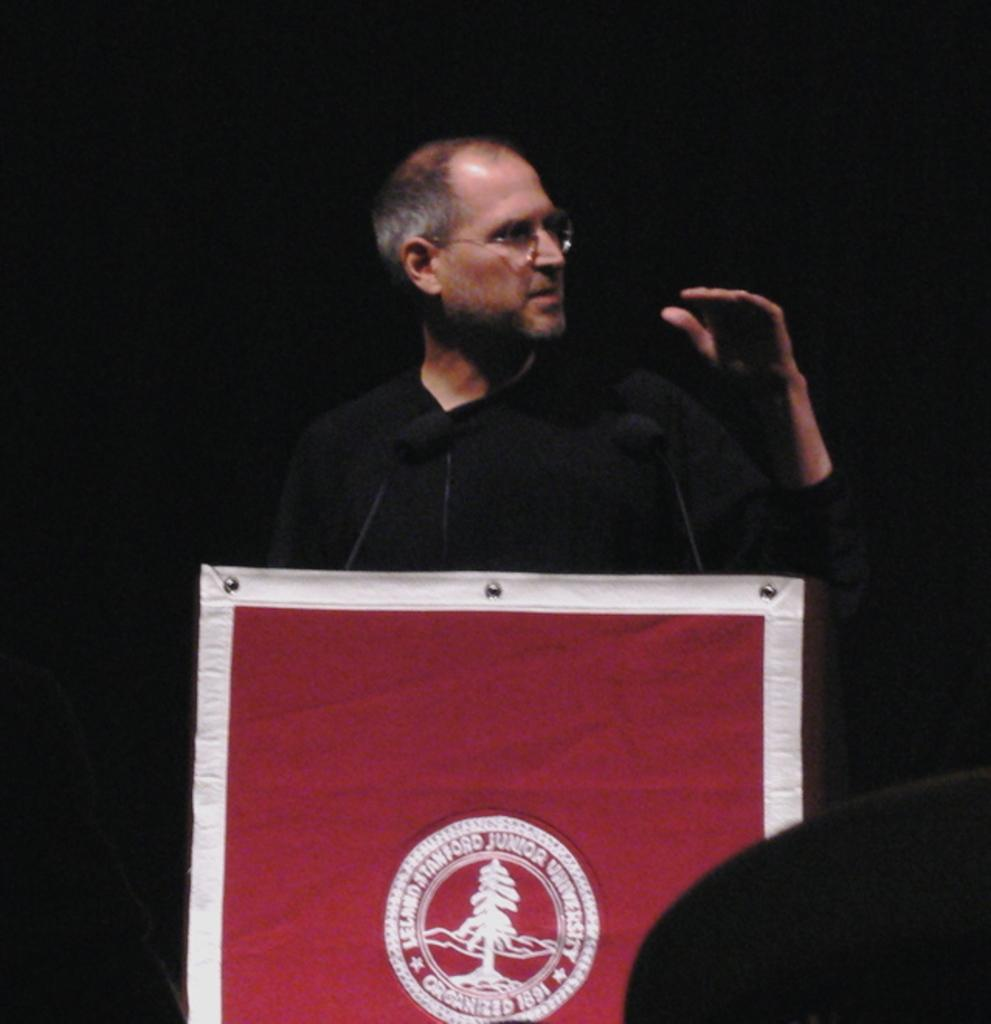Who is present in the image? There is a man in the image. What is the man wearing? The man is wearing spectacles. What is located in front of the man? There is an object in front of the man. What can be seen in the image besides the man? There are microphones (mics) and a poster in the image. How would you describe the background of the image? The background of the image is dark. What type of chairs are visible in the image? There are no chairs present in the image. What arithmetic problem is being solved on the poster? There is no arithmetic problem visible on the poster in the image. 